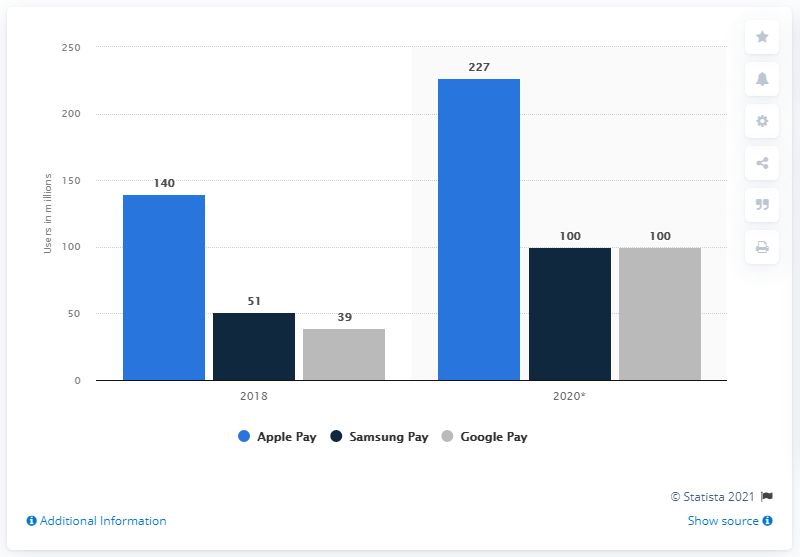Draw attention to some important aspects in this diagram. It is expected that Samsung Pay and Google Pay will have approximately 100 users in 2020. In 2018, the number of users of Apple Pay was 140. It is expected that a significant number of users, approximately 227, will use Apple Pay worldwide. 